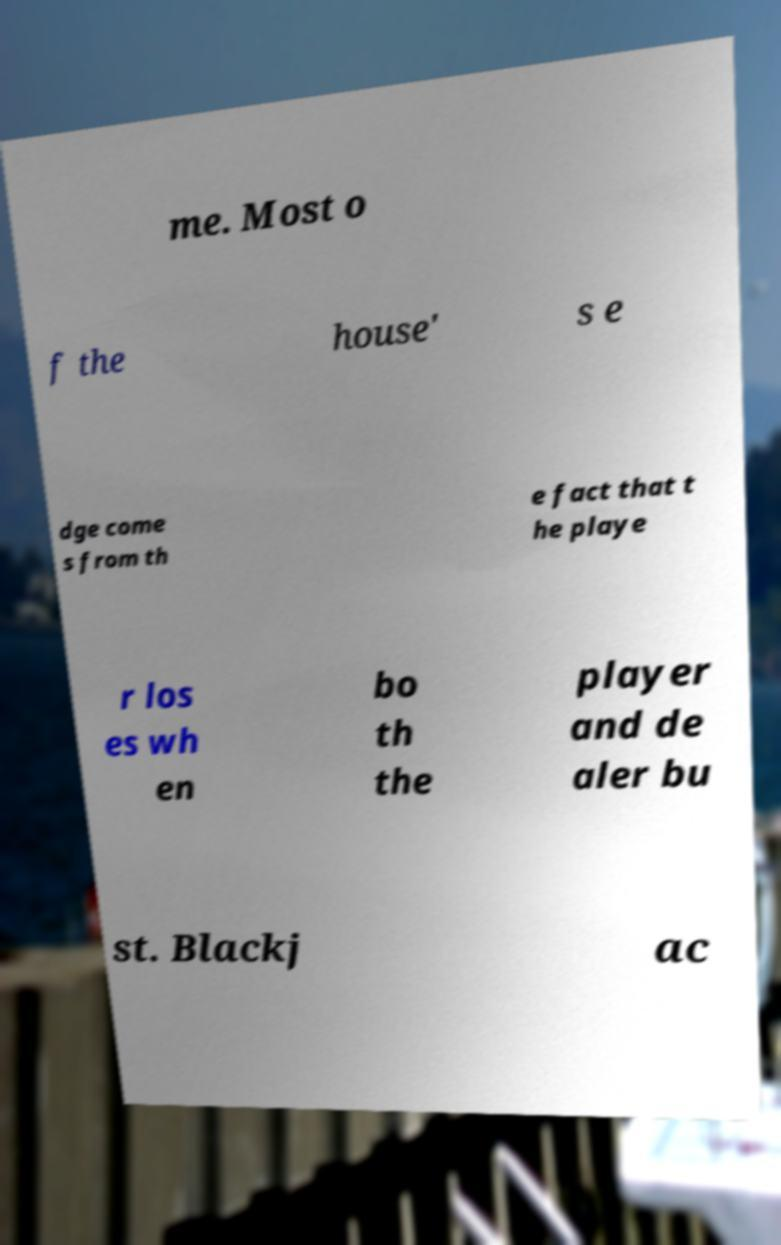Can you read and provide the text displayed in the image?This photo seems to have some interesting text. Can you extract and type it out for me? me. Most o f the house' s e dge come s from th e fact that t he playe r los es wh en bo th the player and de aler bu st. Blackj ac 